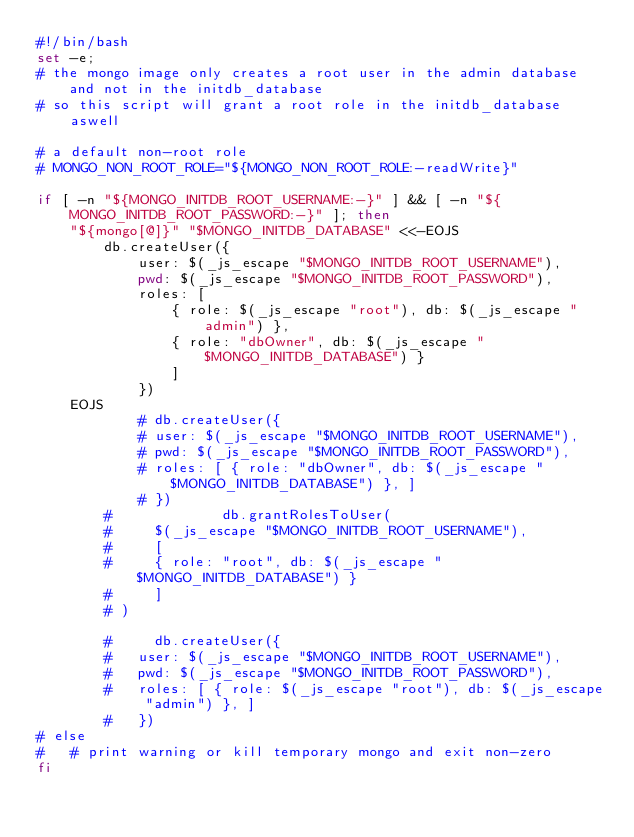Convert code to text. <code><loc_0><loc_0><loc_500><loc_500><_Bash_>#!/bin/bash
set -e;
# the mongo image only creates a root user in the admin database and not in the initdb_database
# so this script will grant a root role in the initdb_database aswell

# a default non-root role
# MONGO_NON_ROOT_ROLE="${MONGO_NON_ROOT_ROLE:-readWrite}"

if [ -n "${MONGO_INITDB_ROOT_USERNAME:-}" ] && [ -n "${MONGO_INITDB_ROOT_PASSWORD:-}" ]; then
	"${mongo[@]}" "$MONGO_INITDB_DATABASE" <<-EOJS
        db.createUser({
            user: $(_js_escape "$MONGO_INITDB_ROOT_USERNAME"),
            pwd: $(_js_escape "$MONGO_INITDB_ROOT_PASSWORD"),
            roles: [ 
                { role: $(_js_escape "root"), db: $(_js_escape "admin") }, 
                { role: "dbOwner", db: $(_js_escape "$MONGO_INITDB_DATABASE") } 
                ]
            })
	EOJS
    		# db.createUser({
			# user: $(_js_escape "$MONGO_INITDB_ROOT_USERNAME"),
			# pwd: $(_js_escape "$MONGO_INITDB_ROOT_PASSWORD"),
			# roles: [ { role: "dbOwner", db: $(_js_escape "$MONGO_INITDB_DATABASE") }, ]
			# })
        #             db.grantRolesToUser(
        #     $(_js_escape "$MONGO_INITDB_ROOT_USERNAME"),
        #     [
        #     { role: "root", db: $(_js_escape "$MONGO_INITDB_DATABASE") }
        #     ]
        # )

        #     db.createUser({
		# 	user: $(_js_escape "$MONGO_INITDB_ROOT_USERNAME"),
		# 	pwd: $(_js_escape "$MONGO_INITDB_ROOT_PASSWORD"),
		# 	roles: [ { role: $(_js_escape "root"), db: $(_js_escape "admin") }, ]
		# 	})
# else
# 	# print warning or kill temporary mongo and exit non-zero
fi</code> 